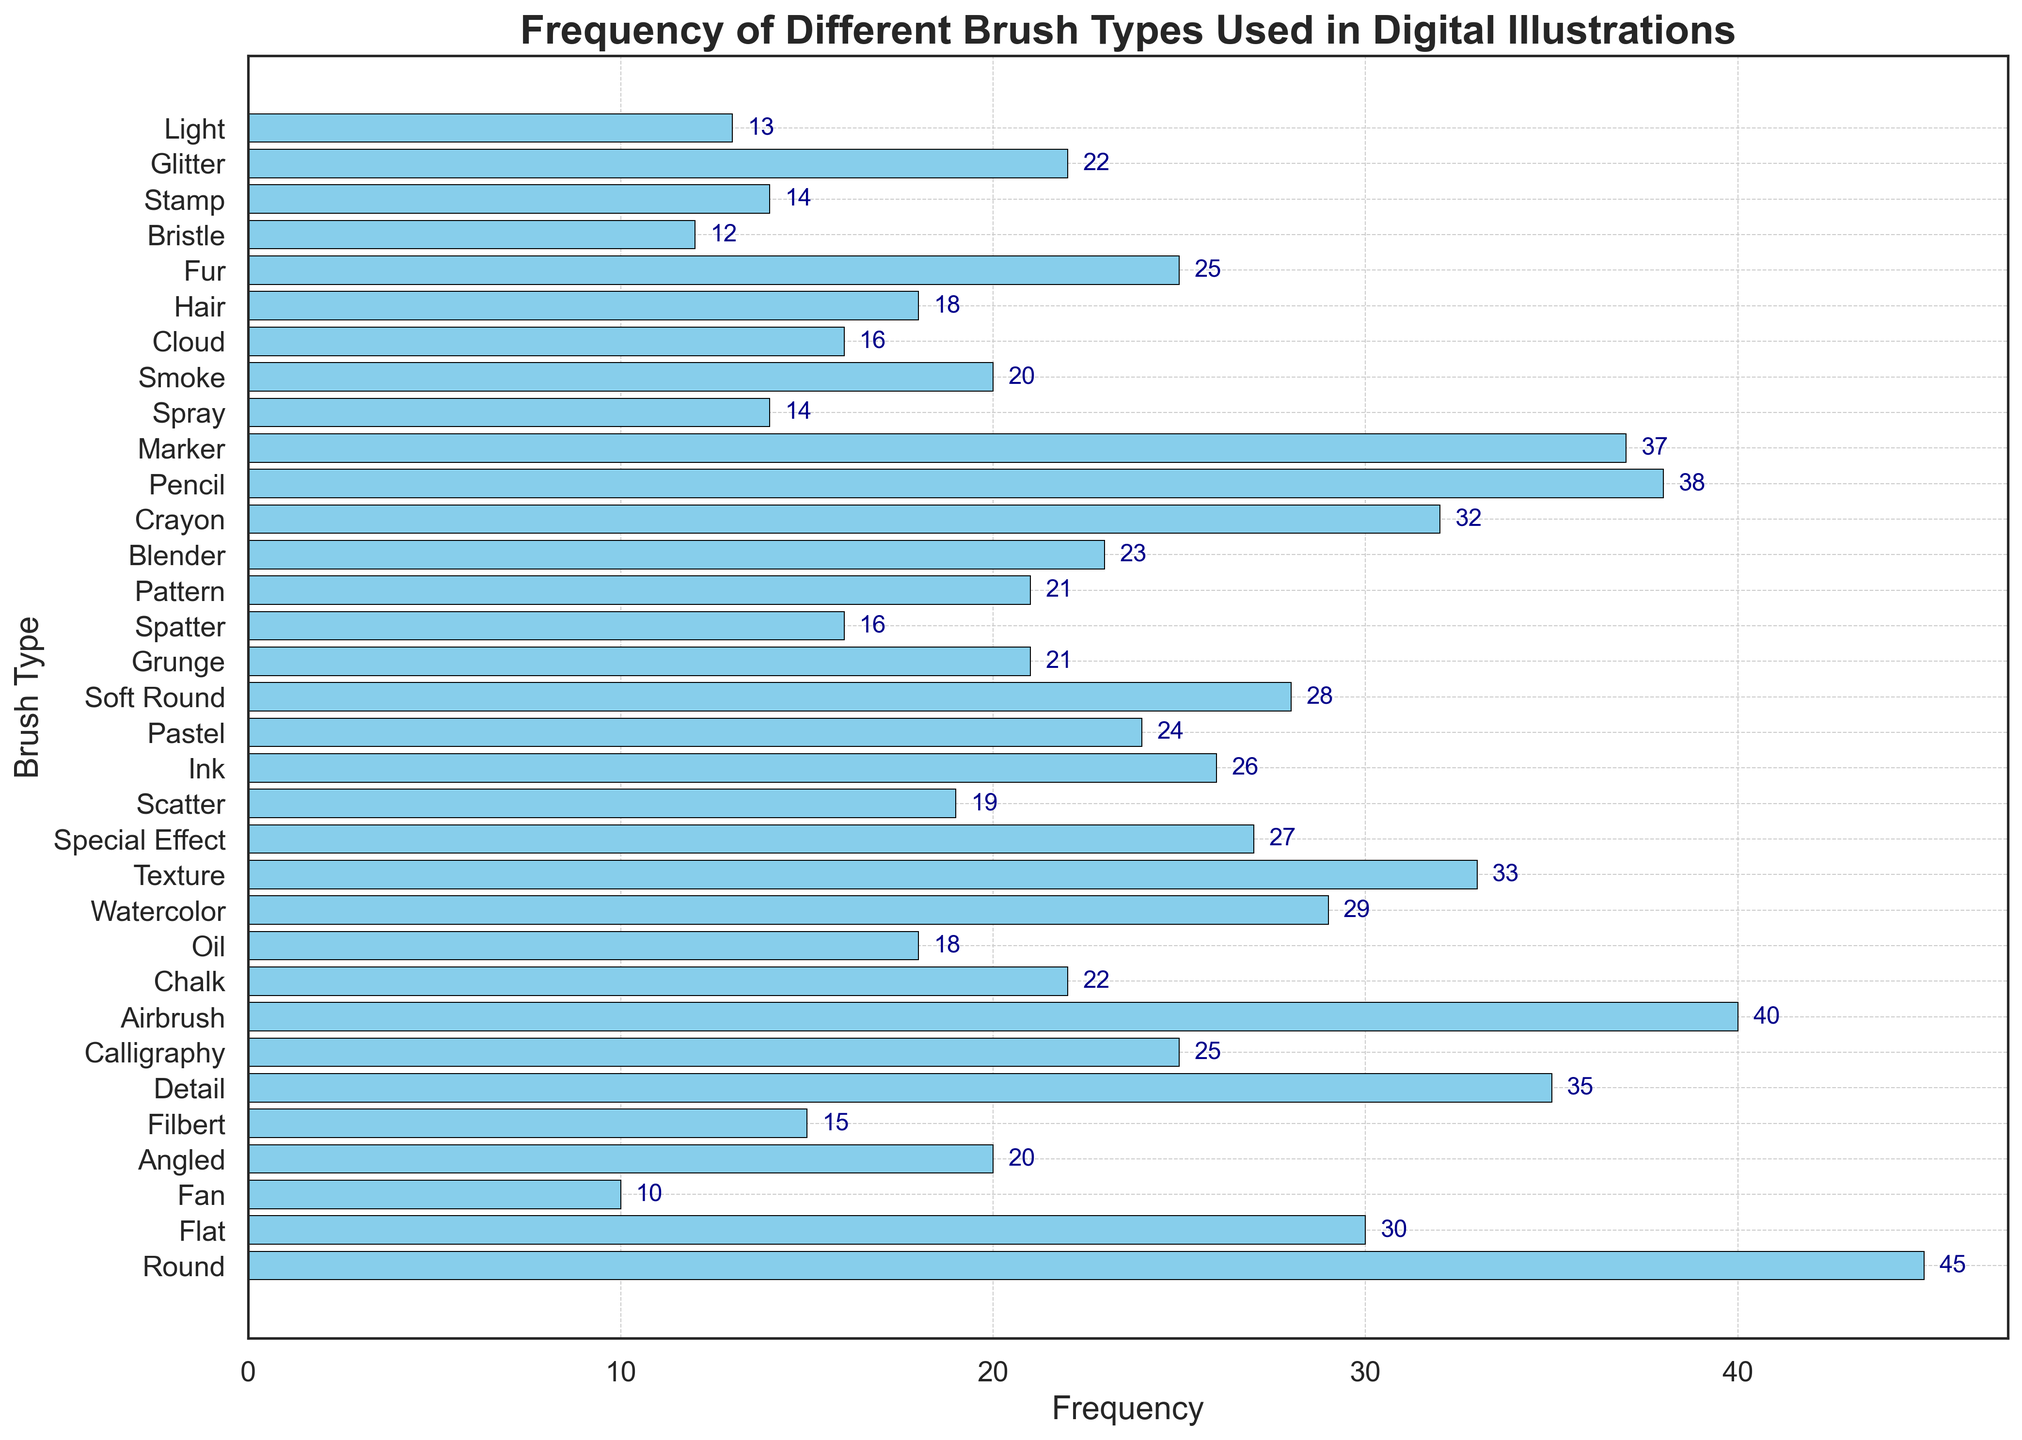Which brush type has the highest frequency? The highest frequency is observed in the brush type with the longest bar. In this case, the 'Round' brush type has the longest bar with a frequency of 45.
Answer: Round Which brush type is used more frequently, 'Airbrush' or 'Detail'? By comparing the lengths of the bars for 'Airbrush' and 'Detail', 'Airbrush' has a frequency of 40 while 'Detail' has a frequency of 35. 'Airbrush' is used more frequently.
Answer: Airbrush What is the total frequency of 'Watercolor', 'Texture', and 'Special Effect' brushes combined? The frequencies for 'Watercolor', 'Texture', and 'Special Effect' are 29, 33, and 27, respectively. Adding these values gives us: 29 + 33 + 27 = 89.
Answer: 89 Which brush type has the smallest frequency? The brush type with the smallest frequency is represented by the shortest bar, which is 'Light' with a frequency of 13.
Answer: Light Are there more brush types with frequencies above 30 or below 20? List frequencies above 30 (Round, Detail, Airbrush, Texture, Pencil, Marker): 45, 35, 40, 33, 38, 37. List frequencies below 20 (Fan, Spatter, Spray, Bristle, Light): 10, 16, 14, 12, 13. There are 6 brush types above 30 and 5 below 20. There are more brush types with frequencies above 30.
Answer: Above 30 What is the average frequency of the 'Round', 'Flat', and 'Fan' brush types? Their frequencies are 45, 30, and 10, respectively. The average is calculated as (45 + 30 + 10) / 3 = 85 / 3 ≈ 28.33.
Answer: 28.33 Which brush type is used less frequently, 'Crayon' or 'Soft Round'? The frequencies of 'Crayon' and 'Soft Round' are 32 and 28, respectively. Since 28 is less than 32, 'Soft Round' is used less frequently.
Answer: Soft Round What is the total frequency of the four brush types with the highest values? The frequencies of the four highest brush types are 'Round' (45), 'Airbrush' (40), 'Pencil' (38), and 'Marker' (37). Their total is 45 + 40 + 38 + 37 = 160.
Answer: 160 What is the difference in frequency between 'Scatter' and 'Chalk'? The frequency of 'Scatter' is 19, and 'Chalk' is 22. The difference is 22 - 19 = 3.
Answer: 3 How many brush types have frequencies between 20 and 30 inclusive? The brush types with frequencies in this range are: 'Calligraphy' (25), 'Watercolor' (29), 'Special Effect' (27), 'Ink' (26), 'Pastel' (24), 'Soft Round' (28), 'Grunge' (21), 'Pattern' (21), 'Blender' (23). There are 9 brush types with frequencies between 20 and 30 inclusive.
Answer: 9 